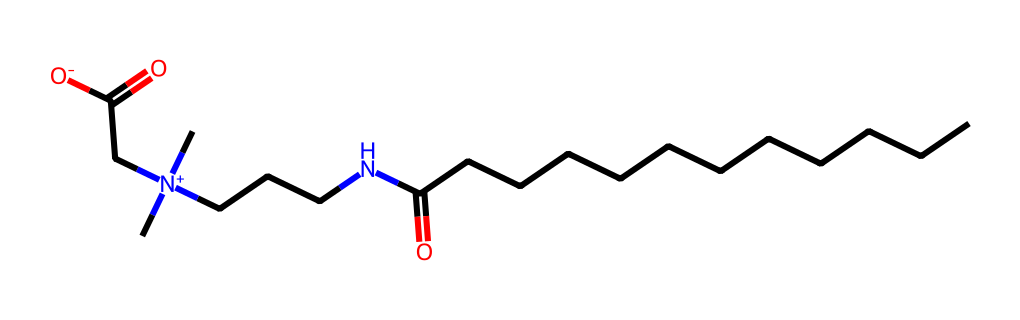What is the longest carbon chain in this molecule? The molecular structure shows a carbon chain of twelve carbon atoms attached to a functional group, represented by the "CCCCCCCCCCCC" portion.
Answer: twelve carbon atoms How many nitrogen atoms are present in the structure? The SMILES representation includes "N" indicating the presence of two nitrogen atoms within the molecular formula.
Answer: two nitrogen atoms What functional group is primarily responsible for the surfactant properties of this molecule? The molecule contains a carboxylate group, denoted as "CC(=O)[O-]", which facilitates the surfactant behavior by reducing surface tension.
Answer: carboxylate group What charge does the nitrogen portion of this molecule carry? The "N+" in the structure indicates that the nitrogen atom has a positive charge due to the three carbon groups attached.
Answer: positive charge How many oxygen atoms are present in this chemical structure? By analyzing the SMILES representation, "O" appears two times, indicating two oxygen atoms in the structure.
Answer: two oxygen atoms How does the arrangement of the hydrophilic and hydrophobic parts affect its properties? The molecule has a long hydrophobic carbon chain and a polar, hydrophilic head containing carboxylate and quaternary amine segments, which allows it to effectively reduce surface tension and interact with water.
Answer: effective surfactant properties 